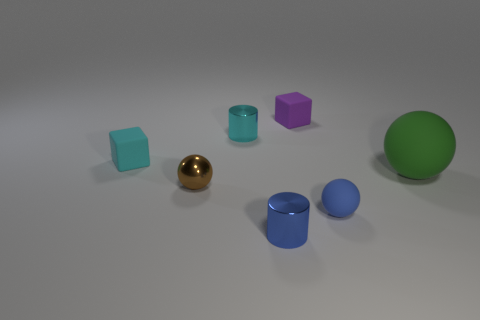Add 1 small cyan shiny objects. How many objects exist? 8 Subtract all balls. How many objects are left? 4 Subtract all small brown metallic balls. Subtract all tiny shiny spheres. How many objects are left? 5 Add 3 blue cylinders. How many blue cylinders are left? 4 Add 7 cyan blocks. How many cyan blocks exist? 8 Subtract 0 purple spheres. How many objects are left? 7 